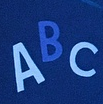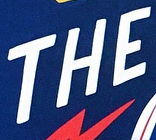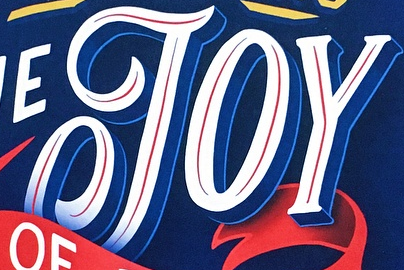What words are shown in these images in order, separated by a semicolon? ABC; THE; JOY 